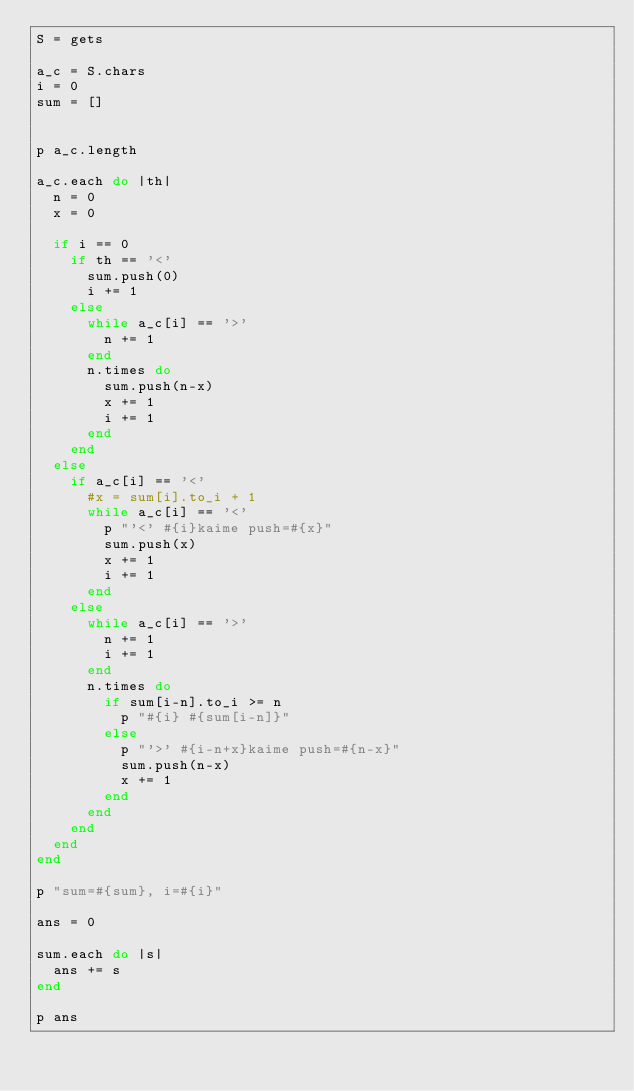Convert code to text. <code><loc_0><loc_0><loc_500><loc_500><_Ruby_>S = gets

a_c = S.chars
i = 0
sum = []


p a_c.length

a_c.each do |th|
  n = 0
  x = 0
  
  if i == 0
    if th == '<'
      sum.push(0)
      i += 1
    else
      while a_c[i] == '>'
        n += 1
      end
      n.times do
        sum.push(n-x)
        x += 1
        i += 1
      end
    end
  else
    if a_c[i] == '<'
      #x = sum[i].to_i + 1
      while a_c[i] == '<'
        p "'<' #{i}kaime push=#{x}"
        sum.push(x)
        x += 1
        i += 1
      end
    else
      while a_c[i] == '>'
        n += 1
        i += 1
      end
      n.times do
        if sum[i-n].to_i >= n
          p "#{i} #{sum[i-n]}"
        else
          p "'>' #{i-n+x}kaime push=#{n-x}"
          sum.push(n-x)
          x += 1
        end
      end
    end
  end
end

p "sum=#{sum}, i=#{i}"

ans = 0

sum.each do |s|
  ans += s
end

p ans</code> 